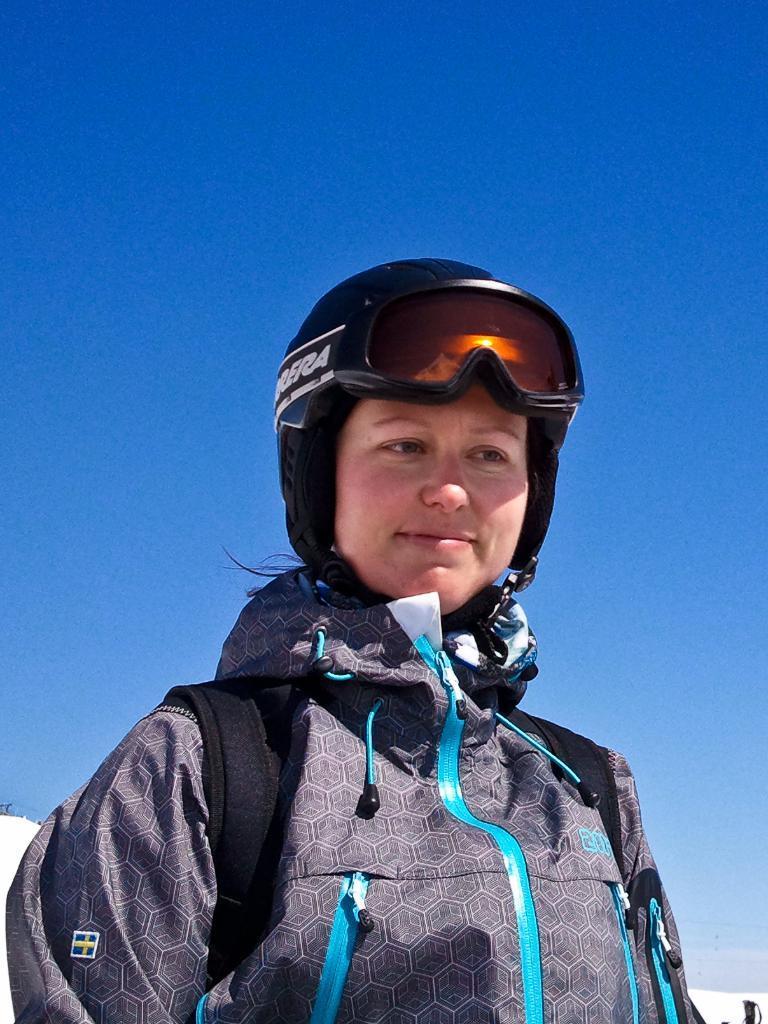Could you give a brief overview of what you see in this image? In this picture we can see a woman wearing helmet and she is wearing a bag. 